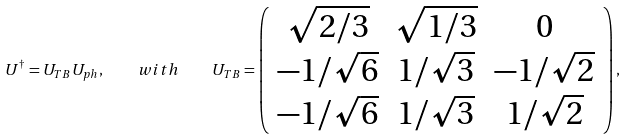Convert formula to latex. <formula><loc_0><loc_0><loc_500><loc_500>U ^ { \dagger } = U _ { T B } U _ { p h } , \quad w i t h \quad U _ { T B } = \left ( \begin{array} { c c c } \sqrt { 2 / 3 } & \sqrt { 1 / 3 } & 0 \\ - 1 / \sqrt { 6 } & 1 / \sqrt { 3 } & - 1 / \sqrt { 2 } \\ - 1 / \sqrt { 6 } & 1 / \sqrt { 3 } & 1 / \sqrt { 2 } \end{array} \right ) ,</formula> 